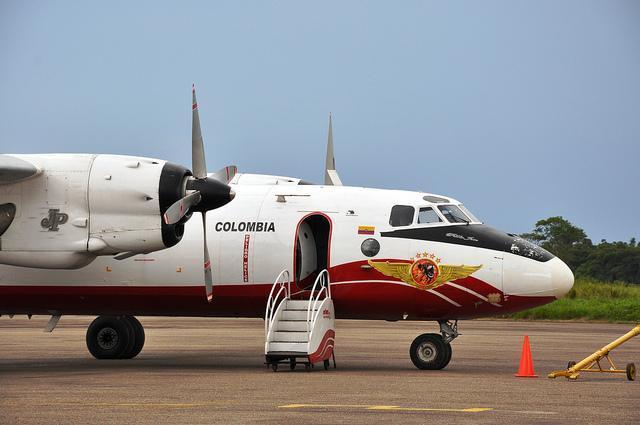How many blades are on the propeller?
Give a very brief answer. 4. How many airplanes are there?
Give a very brief answer. 2. How many trains can be seen?
Give a very brief answer. 0. 